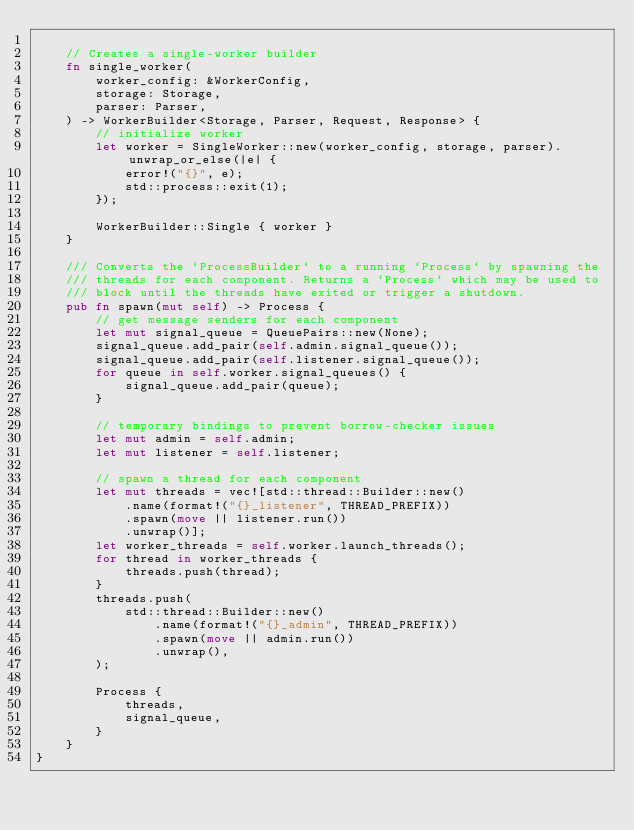<code> <loc_0><loc_0><loc_500><loc_500><_Rust_>
    // Creates a single-worker builder
    fn single_worker(
        worker_config: &WorkerConfig,
        storage: Storage,
        parser: Parser,
    ) -> WorkerBuilder<Storage, Parser, Request, Response> {
        // initialize worker
        let worker = SingleWorker::new(worker_config, storage, parser).unwrap_or_else(|e| {
            error!("{}", e);
            std::process::exit(1);
        });

        WorkerBuilder::Single { worker }
    }

    /// Converts the `ProcessBuilder` to a running `Process` by spawning the
    /// threads for each component. Returns a `Process` which may be used to
    /// block until the threads have exited or trigger a shutdown.
    pub fn spawn(mut self) -> Process {
        // get message senders for each component
        let mut signal_queue = QueuePairs::new(None);
        signal_queue.add_pair(self.admin.signal_queue());
        signal_queue.add_pair(self.listener.signal_queue());
        for queue in self.worker.signal_queues() {
            signal_queue.add_pair(queue);
        }

        // temporary bindings to prevent borrow-checker issues
        let mut admin = self.admin;
        let mut listener = self.listener;

        // spawn a thread for each component
        let mut threads = vec![std::thread::Builder::new()
            .name(format!("{}_listener", THREAD_PREFIX))
            .spawn(move || listener.run())
            .unwrap()];
        let worker_threads = self.worker.launch_threads();
        for thread in worker_threads {
            threads.push(thread);
        }
        threads.push(
            std::thread::Builder::new()
                .name(format!("{}_admin", THREAD_PREFIX))
                .spawn(move || admin.run())
                .unwrap(),
        );

        Process {
            threads,
            signal_queue,
        }
    }
}
</code> 